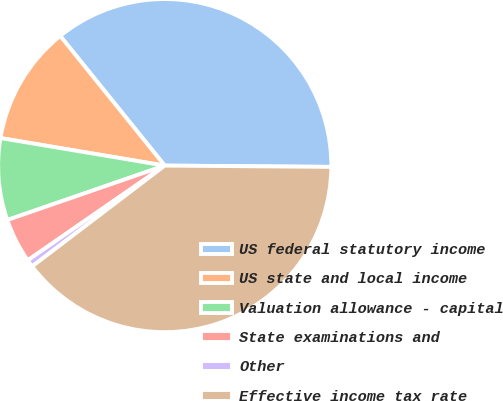Convert chart. <chart><loc_0><loc_0><loc_500><loc_500><pie_chart><fcel>US federal statutory income<fcel>US state and local income<fcel>Valuation allowance - capital<fcel>State examinations and<fcel>Other<fcel>Effective income tax rate<nl><fcel>35.92%<fcel>11.56%<fcel>7.94%<fcel>4.33%<fcel>0.72%<fcel>39.53%<nl></chart> 